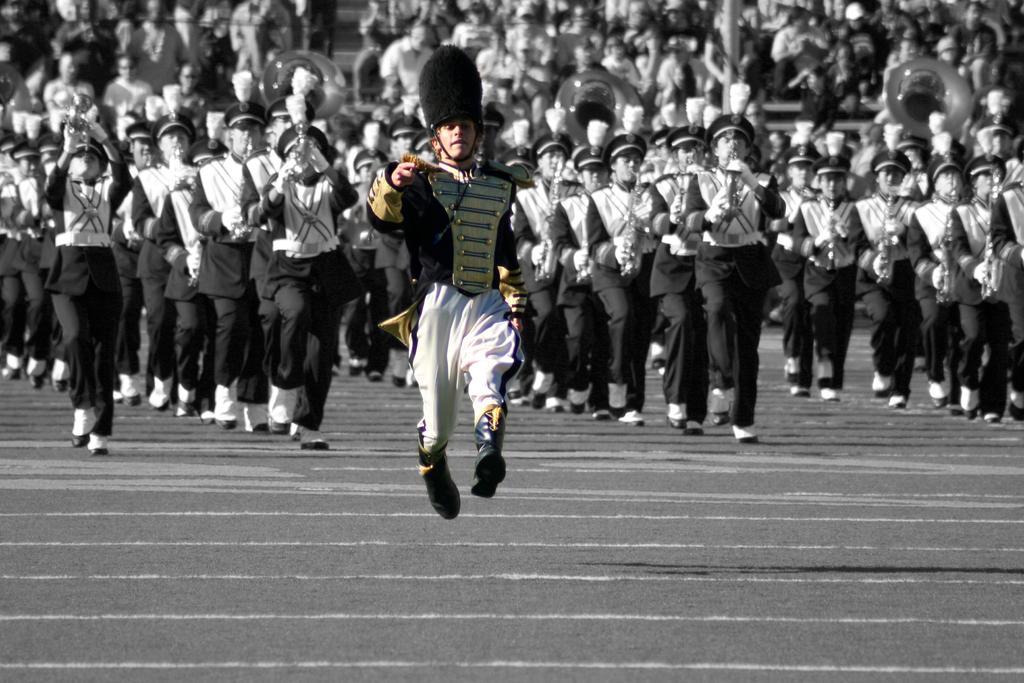Could you give a brief overview of what you see in this image? In this image people are doing march 1st on the ground. At the back side people are sitting on the stairs. 